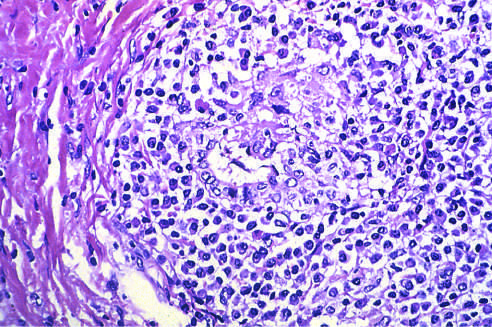s deposition of antibody on endothelium and activation of complement markedly expanded by an infiltrate of lymphocytes and plasma cells?
Answer the question using a single word or phrase. No 